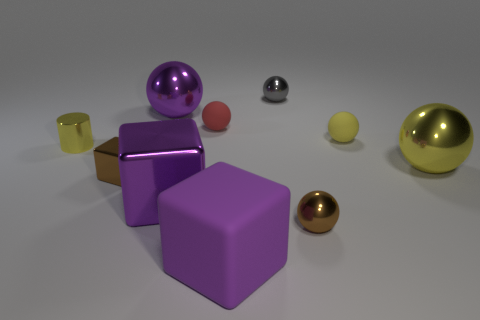What color is the small cube that is made of the same material as the brown ball?
Make the answer very short. Brown. Is the number of large shiny cubes greater than the number of small gray rubber balls?
Keep it short and to the point. Yes. Is the tiny brown cube made of the same material as the purple sphere?
Give a very brief answer. Yes. There is a purple thing that is made of the same material as the tiny yellow sphere; what shape is it?
Provide a succinct answer. Cube. Are there fewer purple things than tiny red spheres?
Ensure brevity in your answer.  No. What is the material of the purple thing that is on the left side of the red matte object and in front of the brown metallic block?
Your answer should be very brief. Metal. How big is the shiny sphere in front of the yellow ball that is in front of the yellow thing that is on the left side of the purple rubber block?
Give a very brief answer. Small. Do the gray object and the tiny brown thing left of the big rubber cube have the same shape?
Your answer should be very brief. No. How many things are both behind the tiny yellow matte ball and left of the red sphere?
Your answer should be very brief. 1. How many yellow things are either metallic things or spheres?
Keep it short and to the point. 3. 